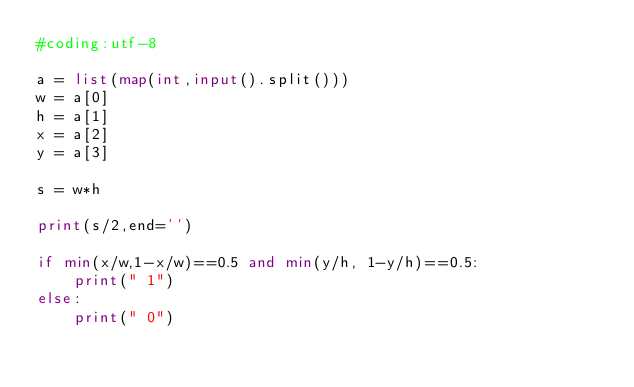Convert code to text. <code><loc_0><loc_0><loc_500><loc_500><_Python_>#coding:utf-8

a = list(map(int,input().split()))
w = a[0]
h = a[1]
x = a[2]
y = a[3]

s = w*h

print(s/2,end='')

if min(x/w,1-x/w)==0.5 and min(y/h, 1-y/h)==0.5:
    print(" 1")
else:
    print(" 0")
</code> 